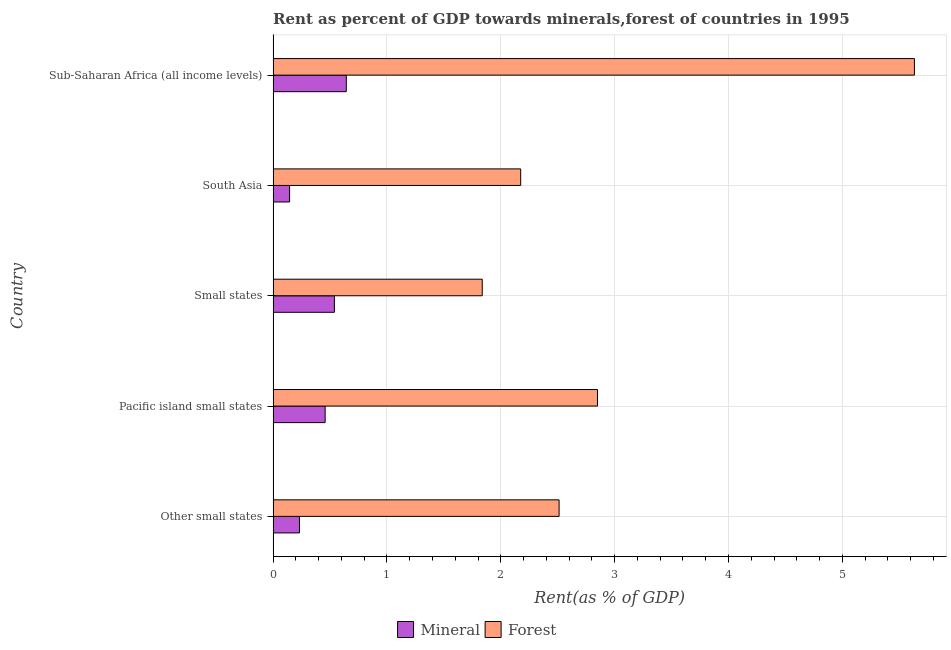How many different coloured bars are there?
Keep it short and to the point. 2. How many groups of bars are there?
Your response must be concise. 5. Are the number of bars on each tick of the Y-axis equal?
Your answer should be compact. Yes. How many bars are there on the 5th tick from the top?
Provide a short and direct response. 2. What is the label of the 4th group of bars from the top?
Your answer should be very brief. Pacific island small states. In how many cases, is the number of bars for a given country not equal to the number of legend labels?
Offer a very short reply. 0. What is the mineral rent in South Asia?
Your response must be concise. 0.14. Across all countries, what is the maximum forest rent?
Give a very brief answer. 5.63. Across all countries, what is the minimum forest rent?
Your answer should be very brief. 1.84. In which country was the forest rent maximum?
Give a very brief answer. Sub-Saharan Africa (all income levels). In which country was the mineral rent minimum?
Your response must be concise. South Asia. What is the total mineral rent in the graph?
Provide a short and direct response. 2.01. What is the difference between the mineral rent in Small states and that in Sub-Saharan Africa (all income levels)?
Provide a succinct answer. -0.1. What is the difference between the mineral rent in Small states and the forest rent in Other small states?
Make the answer very short. -1.97. What is the average mineral rent per country?
Provide a short and direct response. 0.4. What is the difference between the forest rent and mineral rent in Sub-Saharan Africa (all income levels)?
Keep it short and to the point. 4.99. What is the ratio of the mineral rent in Pacific island small states to that in Small states?
Your answer should be very brief. 0.85. Is the difference between the forest rent in Small states and Sub-Saharan Africa (all income levels) greater than the difference between the mineral rent in Small states and Sub-Saharan Africa (all income levels)?
Provide a succinct answer. No. What is the difference between the highest and the second highest mineral rent?
Offer a terse response. 0.1. What is the difference between the highest and the lowest mineral rent?
Give a very brief answer. 0.5. In how many countries, is the mineral rent greater than the average mineral rent taken over all countries?
Offer a very short reply. 3. What does the 1st bar from the top in Pacific island small states represents?
Provide a short and direct response. Forest. What does the 1st bar from the bottom in Other small states represents?
Provide a short and direct response. Mineral. Are all the bars in the graph horizontal?
Provide a short and direct response. Yes. What is the difference between two consecutive major ticks on the X-axis?
Provide a short and direct response. 1. Are the values on the major ticks of X-axis written in scientific E-notation?
Offer a very short reply. No. Does the graph contain any zero values?
Your answer should be compact. No. Does the graph contain grids?
Give a very brief answer. Yes. Where does the legend appear in the graph?
Ensure brevity in your answer.  Bottom center. How many legend labels are there?
Your answer should be very brief. 2. How are the legend labels stacked?
Provide a short and direct response. Horizontal. What is the title of the graph?
Your response must be concise. Rent as percent of GDP towards minerals,forest of countries in 1995. Does "Services" appear as one of the legend labels in the graph?
Your answer should be very brief. No. What is the label or title of the X-axis?
Keep it short and to the point. Rent(as % of GDP). What is the Rent(as % of GDP) in Mineral in Other small states?
Provide a short and direct response. 0.23. What is the Rent(as % of GDP) of Forest in Other small states?
Provide a succinct answer. 2.51. What is the Rent(as % of GDP) of Mineral in Pacific island small states?
Make the answer very short. 0.46. What is the Rent(as % of GDP) in Forest in Pacific island small states?
Give a very brief answer. 2.85. What is the Rent(as % of GDP) of Mineral in Small states?
Offer a terse response. 0.54. What is the Rent(as % of GDP) of Forest in Small states?
Provide a succinct answer. 1.84. What is the Rent(as % of GDP) of Mineral in South Asia?
Ensure brevity in your answer.  0.14. What is the Rent(as % of GDP) of Forest in South Asia?
Give a very brief answer. 2.17. What is the Rent(as % of GDP) of Mineral in Sub-Saharan Africa (all income levels)?
Make the answer very short. 0.64. What is the Rent(as % of GDP) of Forest in Sub-Saharan Africa (all income levels)?
Keep it short and to the point. 5.63. Across all countries, what is the maximum Rent(as % of GDP) in Mineral?
Ensure brevity in your answer.  0.64. Across all countries, what is the maximum Rent(as % of GDP) of Forest?
Your response must be concise. 5.63. Across all countries, what is the minimum Rent(as % of GDP) in Mineral?
Offer a very short reply. 0.14. Across all countries, what is the minimum Rent(as % of GDP) in Forest?
Your answer should be compact. 1.84. What is the total Rent(as % of GDP) of Mineral in the graph?
Provide a short and direct response. 2.01. What is the total Rent(as % of GDP) of Forest in the graph?
Offer a very short reply. 15.01. What is the difference between the Rent(as % of GDP) in Mineral in Other small states and that in Pacific island small states?
Your answer should be compact. -0.23. What is the difference between the Rent(as % of GDP) of Forest in Other small states and that in Pacific island small states?
Provide a succinct answer. -0.34. What is the difference between the Rent(as % of GDP) of Mineral in Other small states and that in Small states?
Give a very brief answer. -0.31. What is the difference between the Rent(as % of GDP) of Forest in Other small states and that in Small states?
Your answer should be compact. 0.68. What is the difference between the Rent(as % of GDP) in Mineral in Other small states and that in South Asia?
Provide a succinct answer. 0.09. What is the difference between the Rent(as % of GDP) of Forest in Other small states and that in South Asia?
Ensure brevity in your answer.  0.34. What is the difference between the Rent(as % of GDP) in Mineral in Other small states and that in Sub-Saharan Africa (all income levels)?
Your response must be concise. -0.41. What is the difference between the Rent(as % of GDP) in Forest in Other small states and that in Sub-Saharan Africa (all income levels)?
Your response must be concise. -3.12. What is the difference between the Rent(as % of GDP) of Mineral in Pacific island small states and that in Small states?
Provide a short and direct response. -0.08. What is the difference between the Rent(as % of GDP) of Forest in Pacific island small states and that in Small states?
Your answer should be very brief. 1.01. What is the difference between the Rent(as % of GDP) in Mineral in Pacific island small states and that in South Asia?
Keep it short and to the point. 0.31. What is the difference between the Rent(as % of GDP) of Forest in Pacific island small states and that in South Asia?
Provide a succinct answer. 0.67. What is the difference between the Rent(as % of GDP) of Mineral in Pacific island small states and that in Sub-Saharan Africa (all income levels)?
Your response must be concise. -0.19. What is the difference between the Rent(as % of GDP) in Forest in Pacific island small states and that in Sub-Saharan Africa (all income levels)?
Your response must be concise. -2.78. What is the difference between the Rent(as % of GDP) of Mineral in Small states and that in South Asia?
Offer a terse response. 0.39. What is the difference between the Rent(as % of GDP) in Forest in Small states and that in South Asia?
Provide a succinct answer. -0.34. What is the difference between the Rent(as % of GDP) of Mineral in Small states and that in Sub-Saharan Africa (all income levels)?
Your response must be concise. -0.1. What is the difference between the Rent(as % of GDP) in Forest in Small states and that in Sub-Saharan Africa (all income levels)?
Provide a succinct answer. -3.8. What is the difference between the Rent(as % of GDP) in Mineral in South Asia and that in Sub-Saharan Africa (all income levels)?
Your response must be concise. -0.5. What is the difference between the Rent(as % of GDP) in Forest in South Asia and that in Sub-Saharan Africa (all income levels)?
Your response must be concise. -3.46. What is the difference between the Rent(as % of GDP) in Mineral in Other small states and the Rent(as % of GDP) in Forest in Pacific island small states?
Keep it short and to the point. -2.62. What is the difference between the Rent(as % of GDP) of Mineral in Other small states and the Rent(as % of GDP) of Forest in Small states?
Offer a terse response. -1.61. What is the difference between the Rent(as % of GDP) of Mineral in Other small states and the Rent(as % of GDP) of Forest in South Asia?
Provide a short and direct response. -1.94. What is the difference between the Rent(as % of GDP) in Mineral in Other small states and the Rent(as % of GDP) in Forest in Sub-Saharan Africa (all income levels)?
Your response must be concise. -5.4. What is the difference between the Rent(as % of GDP) of Mineral in Pacific island small states and the Rent(as % of GDP) of Forest in Small states?
Offer a terse response. -1.38. What is the difference between the Rent(as % of GDP) in Mineral in Pacific island small states and the Rent(as % of GDP) in Forest in South Asia?
Ensure brevity in your answer.  -1.72. What is the difference between the Rent(as % of GDP) in Mineral in Pacific island small states and the Rent(as % of GDP) in Forest in Sub-Saharan Africa (all income levels)?
Ensure brevity in your answer.  -5.18. What is the difference between the Rent(as % of GDP) of Mineral in Small states and the Rent(as % of GDP) of Forest in South Asia?
Give a very brief answer. -1.64. What is the difference between the Rent(as % of GDP) of Mineral in Small states and the Rent(as % of GDP) of Forest in Sub-Saharan Africa (all income levels)?
Offer a terse response. -5.1. What is the difference between the Rent(as % of GDP) in Mineral in South Asia and the Rent(as % of GDP) in Forest in Sub-Saharan Africa (all income levels)?
Provide a short and direct response. -5.49. What is the average Rent(as % of GDP) in Mineral per country?
Keep it short and to the point. 0.4. What is the average Rent(as % of GDP) in Forest per country?
Offer a very short reply. 3. What is the difference between the Rent(as % of GDP) of Mineral and Rent(as % of GDP) of Forest in Other small states?
Provide a short and direct response. -2.28. What is the difference between the Rent(as % of GDP) in Mineral and Rent(as % of GDP) in Forest in Pacific island small states?
Provide a succinct answer. -2.39. What is the difference between the Rent(as % of GDP) in Mineral and Rent(as % of GDP) in Forest in Small states?
Your answer should be compact. -1.3. What is the difference between the Rent(as % of GDP) of Mineral and Rent(as % of GDP) of Forest in South Asia?
Provide a succinct answer. -2.03. What is the difference between the Rent(as % of GDP) of Mineral and Rent(as % of GDP) of Forest in Sub-Saharan Africa (all income levels)?
Make the answer very short. -4.99. What is the ratio of the Rent(as % of GDP) in Mineral in Other small states to that in Pacific island small states?
Provide a short and direct response. 0.51. What is the ratio of the Rent(as % of GDP) in Forest in Other small states to that in Pacific island small states?
Offer a very short reply. 0.88. What is the ratio of the Rent(as % of GDP) of Mineral in Other small states to that in Small states?
Give a very brief answer. 0.43. What is the ratio of the Rent(as % of GDP) of Forest in Other small states to that in Small states?
Offer a very short reply. 1.37. What is the ratio of the Rent(as % of GDP) in Mineral in Other small states to that in South Asia?
Provide a short and direct response. 1.6. What is the ratio of the Rent(as % of GDP) of Forest in Other small states to that in South Asia?
Your answer should be compact. 1.16. What is the ratio of the Rent(as % of GDP) of Mineral in Other small states to that in Sub-Saharan Africa (all income levels)?
Your answer should be very brief. 0.36. What is the ratio of the Rent(as % of GDP) in Forest in Other small states to that in Sub-Saharan Africa (all income levels)?
Offer a terse response. 0.45. What is the ratio of the Rent(as % of GDP) of Mineral in Pacific island small states to that in Small states?
Provide a short and direct response. 0.85. What is the ratio of the Rent(as % of GDP) in Forest in Pacific island small states to that in Small states?
Your response must be concise. 1.55. What is the ratio of the Rent(as % of GDP) of Mineral in Pacific island small states to that in South Asia?
Offer a very short reply. 3.16. What is the ratio of the Rent(as % of GDP) in Forest in Pacific island small states to that in South Asia?
Offer a very short reply. 1.31. What is the ratio of the Rent(as % of GDP) in Mineral in Pacific island small states to that in Sub-Saharan Africa (all income levels)?
Keep it short and to the point. 0.71. What is the ratio of the Rent(as % of GDP) in Forest in Pacific island small states to that in Sub-Saharan Africa (all income levels)?
Your answer should be compact. 0.51. What is the ratio of the Rent(as % of GDP) in Mineral in Small states to that in South Asia?
Ensure brevity in your answer.  3.72. What is the ratio of the Rent(as % of GDP) of Forest in Small states to that in South Asia?
Your answer should be compact. 0.84. What is the ratio of the Rent(as % of GDP) of Mineral in Small states to that in Sub-Saharan Africa (all income levels)?
Offer a very short reply. 0.84. What is the ratio of the Rent(as % of GDP) of Forest in Small states to that in Sub-Saharan Africa (all income levels)?
Make the answer very short. 0.33. What is the ratio of the Rent(as % of GDP) in Mineral in South Asia to that in Sub-Saharan Africa (all income levels)?
Ensure brevity in your answer.  0.23. What is the ratio of the Rent(as % of GDP) of Forest in South Asia to that in Sub-Saharan Africa (all income levels)?
Your response must be concise. 0.39. What is the difference between the highest and the second highest Rent(as % of GDP) of Mineral?
Give a very brief answer. 0.1. What is the difference between the highest and the second highest Rent(as % of GDP) in Forest?
Give a very brief answer. 2.78. What is the difference between the highest and the lowest Rent(as % of GDP) of Mineral?
Your answer should be very brief. 0.5. What is the difference between the highest and the lowest Rent(as % of GDP) of Forest?
Make the answer very short. 3.8. 